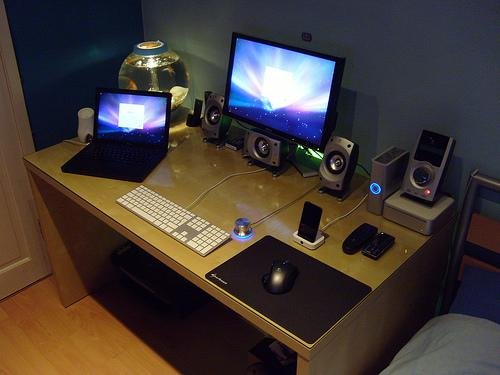What is unique about the lighting in the fish bowl? There is light glare present in the fish bowl. How many electronic items are visible on the desk? Eight electronic items are visible on the desk. List three objects that can be found on the desk. Laptop, fish bowl, and computer display. Mention one interaction seen between the objects in the image. A black mouse is placed on a black mouse pad. What type of floor is visible in the image? Light brown hardwood floor. What type of chair is placed near the desk? Wooden chair with silver frame and blue cushions. Can the fish in the fishbowl be seen in the image? Yes, fish in the fish bowl can be seen in the image. What color is the wall next to the white door? Dark blue. Can you find any diagrams or charts in the image? No, there are no diagrams or charts in the image. What is happening with the equipment on the desk? The equipment on the desk seems idle or is being charged. Describe the computer keyboard on the desk. The computer keyboard is white and gray. What is the dominant color of the wall behind the desk? Light blue Does the laptop screen turned on? Yes What color is the mouse pad on the table? Black While looking at the image, identify if there is a fish in the fishbowl. Yes, there is a fish in the fishbowl. Create a short narrative about the objects and their locations in the room using a conversational tone. Hey! I was checking out this cool room and saw an awesome desk with a black mouse on a black mouse pad, a computer screen, a laptop, and speakers. The desk also had a fish bowl with a goldfish, an iPod on a dock, and a cellphone. There's a wooden chair with blue cushions nearby, and the walls are light and dark blue. The floor is light brown hardwood. It's a pretty neat setup! Create a multi-modal description of the scene, including visual and textual elements. In the image, we can see various objects on and around the desk - a black mouse on a black mouse pad, computer displays, a laptop, a white and gray keyboard, a control set, speakers, a cellphone, and a fishbowl with a goldfish. The desk is placed against a light blue wall and adjacent to a dark blue wall beside a white door. A light brown hardwood floor complements the room's color scheme. Overall, the room appears to be a cozy and functional workspace. Determine if there is an event happening in the scene. No events are happening in the scene. Describe the cushion on the chair next to the desk. The cushion is blue. Is there any furniture located next to the white door? No, there is no furniture next to the white door. Please choose the best description for the chair near the desk: a) old rocking chair b) wooden chair with blue cushions c) white plastic chair b) wooden chair with blue cushions Which object is placed on the charger? Cellphone Is there any text or written information available in the image? No, there isn't any text or written information in the image. Identify the animal present in the scene. Goldfish Describe the scene including objects, colors, and positions in a formal tone. The scene includes a black mouse on a black mouse pad, a light glare on the mouse, a fish bowl with a goldfish in the desk corner, an iPod charging in a dock, a wooden chair with a silver frame and blue cushions, a dark shadow under the desk, light brown hardwood floor, a dark blue wall next to a white door, and a light blue wall behind the desk. There are also computer displays on the table, a laptop, a white and gray keyboard, a control set, and speakers beside the monitor. A cellphone is also placed on the desk. 